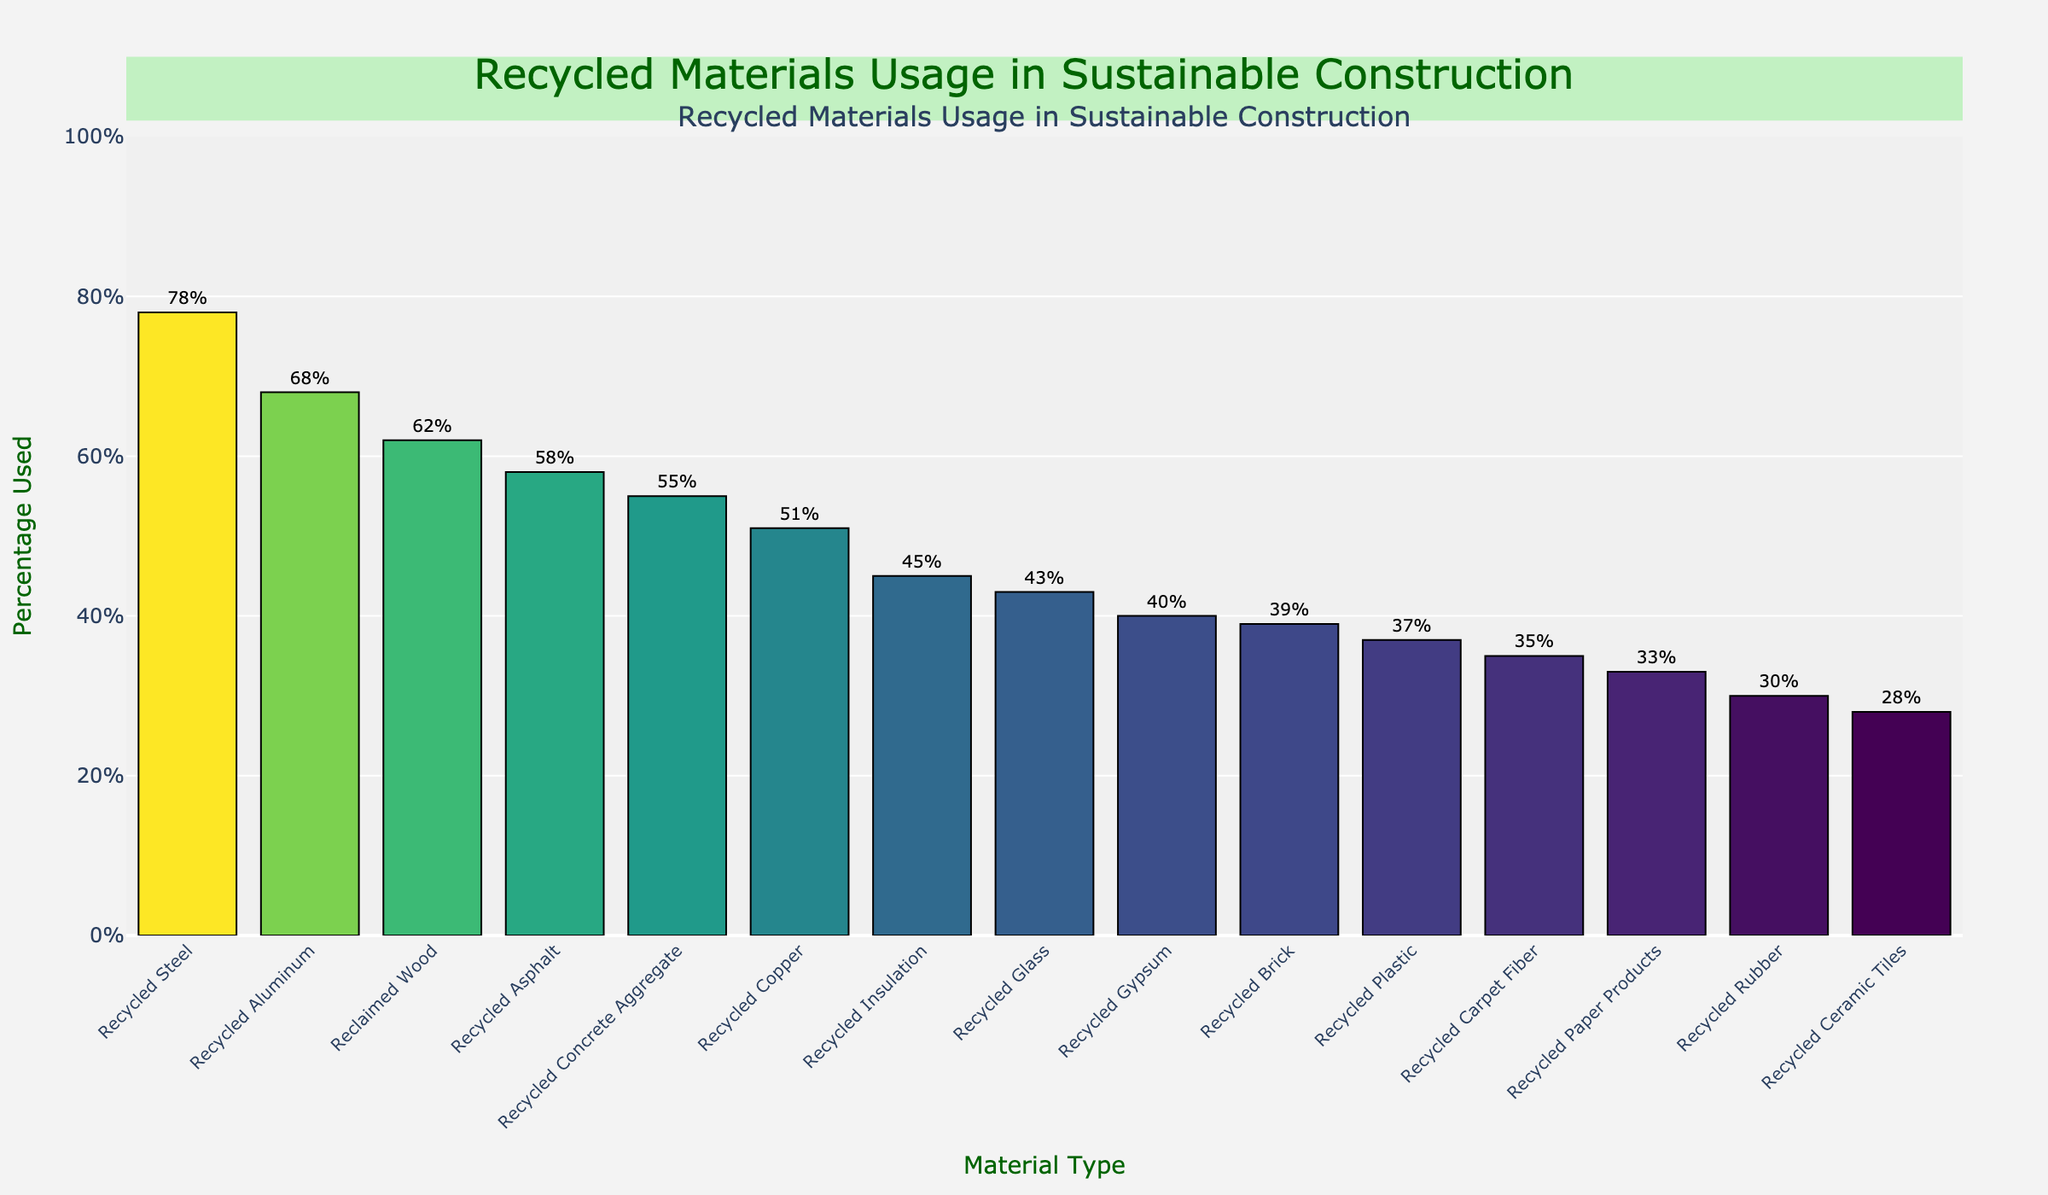What's the material with the highest percentage of recycled content used? To find the material with the highest percentage of recycled content, look for the tallest bar in the chart which corresponds to the highest value. The label for this bar will indicate the material type.
Answer: Recycled Steel What's the difference in percentage usage between Recycled Aluminum and Recycled Plastic? First, locate the bars for Recycled Aluminum and Recycled Plastic in the chart. Note their corresponding percentages, then subtract the percentage for Recycled Plastic from the percentage for Recycled Aluminum: 68% - 37% = 31%.
Answer: 31% Which material has the lowest percentage of recycled content used? Find the shortest bar in the chart as it represents the material with the lowest recycled content percentage. The label on this bar indicates the material type.
Answer: Recycled Ceramic Tiles What is the average percentage of recycled content used among Recycled Steel, Recycled Concrete Aggregate, and Recycled Rubber? Identify the bars for Recycled Steel, Recycled Concrete Aggregate, and Recycled Rubber. Note their percentages: 78%, 55%, and 30%. Then, calculate their average: (78 + 55 + 30) / 3 = 54.33%.
Answer: 54.33% How much higher is the percentage of recycled Reclaimed Wood compared to Recycled Paper Products? Find the bars labeled Reclaimed Wood and Recycled Paper Products in the chart. Note their percentages: 62% and 33%. Subtract the percentage for Recycled Paper Products from Reclaimed Wood: 62% - 33% = 29%.
Answer: 29% How many materials have a recycled content percentage of over 50%? Count the number of bars that extend beyond the 50% mark on the vertical axis.
Answer: 5 Which has a higher percentage of recycled content used: Recycled Glass or Recycled Insulation? Compare the heights of the bars for Recycled Glass and Recycled Insulation. Recycled Insulation has a higher percentage.
Answer: Recycled Insulation What is the total percentage of recycled content used for Recycled Gypsum, Recycled Asphalt, and Recycled Brick? Identify the bars and note their percentages: Recycled Gypsum (40%), Recycled Asphalt (58%), and Recycled Brick (39%). Sum these percentages: 40 + 58 + 39 = 137%.
Answer: 137% Which material has a percentage usage closest to the average percentage of all materials? First, calculate the average percentage for all materials by summing all values and dividing by the number of materials: (78+62+55+43+37+30+68+51+40+35+28+45+58+33+39) / 15 ≈ 47.6%. Then, find the material with a percentage closest to this average. Recycled Glass, with 43%, is the closest.
Answer: Recycled Glass Is the percentage of recycled content higher for Recycled Copper or Recycled Carpet Fiber? Compare the heights of the bars for Recycled Copper and Recycled Carpet Fiber. Recycled Copper has a higher percentage.
Answer: Recycled Copper 